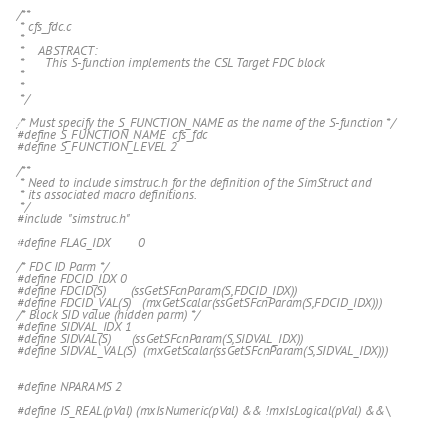Convert code to text. <code><loc_0><loc_0><loc_500><loc_500><_C_>/**
 * cfs_fdc.c
 *
 *    ABSTRACT:
 *      This S-function implements the CSL Target FDC block
 *
 *
 */

/* Must specify the S_FUNCTION_NAME as the name of the S-function */
#define S_FUNCTION_NAME  cfs_fdc
#define S_FUNCTION_LEVEL 2

/**
 * Need to include simstruc.h for the definition of the SimStruct and
 * its associated macro definitions.
 */
#include "simstruc.h"

#define FLAG_IDX        0

/* FDC ID Parm */
#define FDCID_IDX 0
#define FDCID(S)       (ssGetSFcnParam(S,FDCID_IDX))
#define FDCID_VAL(S)   (mxGetScalar(ssGetSFcnParam(S,FDCID_IDX)))
/* Block SID value (hidden parm) */
#define SIDVAL_IDX 1
#define SIDVAL(S)      (ssGetSFcnParam(S,SIDVAL_IDX))
#define SIDVAL_VAL(S)  (mxGetScalar(ssGetSFcnParam(S,SIDVAL_IDX)))


#define NPARAMS 2

#define IS_REAL(pVal) (mxIsNumeric(pVal) && !mxIsLogical(pVal) &&\</code> 